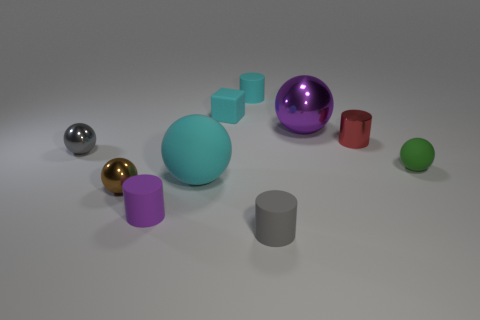Subtract all purple spheres. How many spheres are left? 4 Subtract all small matte cylinders. How many cylinders are left? 1 Subtract 3 balls. How many balls are left? 2 Subtract all yellow cylinders. Subtract all gray blocks. How many cylinders are left? 4 Subtract all cubes. How many objects are left? 9 Subtract all green spheres. Subtract all cylinders. How many objects are left? 5 Add 3 small purple rubber cylinders. How many small purple rubber cylinders are left? 4 Add 9 purple balls. How many purple balls exist? 10 Subtract 1 purple balls. How many objects are left? 9 